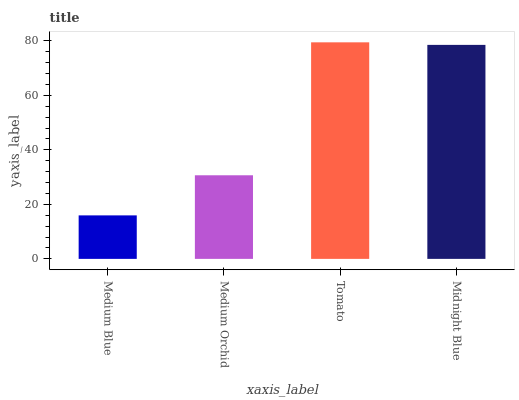Is Medium Blue the minimum?
Answer yes or no. Yes. Is Tomato the maximum?
Answer yes or no. Yes. Is Medium Orchid the minimum?
Answer yes or no. No. Is Medium Orchid the maximum?
Answer yes or no. No. Is Medium Orchid greater than Medium Blue?
Answer yes or no. Yes. Is Medium Blue less than Medium Orchid?
Answer yes or no. Yes. Is Medium Blue greater than Medium Orchid?
Answer yes or no. No. Is Medium Orchid less than Medium Blue?
Answer yes or no. No. Is Midnight Blue the high median?
Answer yes or no. Yes. Is Medium Orchid the low median?
Answer yes or no. Yes. Is Medium Orchid the high median?
Answer yes or no. No. Is Midnight Blue the low median?
Answer yes or no. No. 